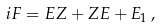<formula> <loc_0><loc_0><loc_500><loc_500>i F = E Z + Z E + E _ { 1 } \, ,</formula> 